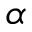Convert formula to latex. <formula><loc_0><loc_0><loc_500><loc_500>\alpha</formula> 